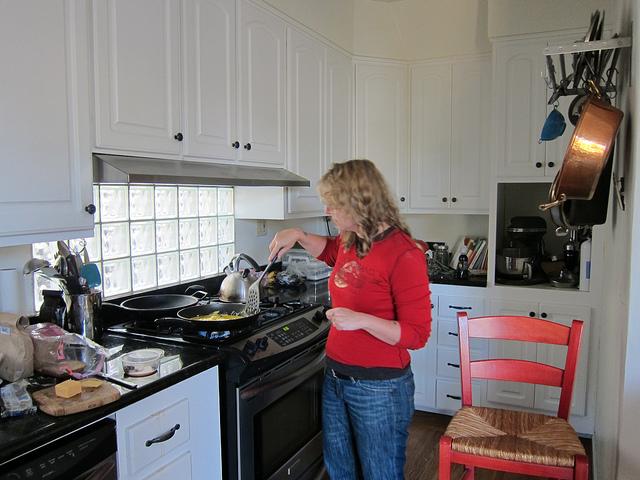What is on the little brown cutting board above the dishwasher?
Short answer required. Cheese. Do these people spend a lot of money on things for their kitchen?
Be succinct. Yes. What color is the chair?
Quick response, please. Red. 